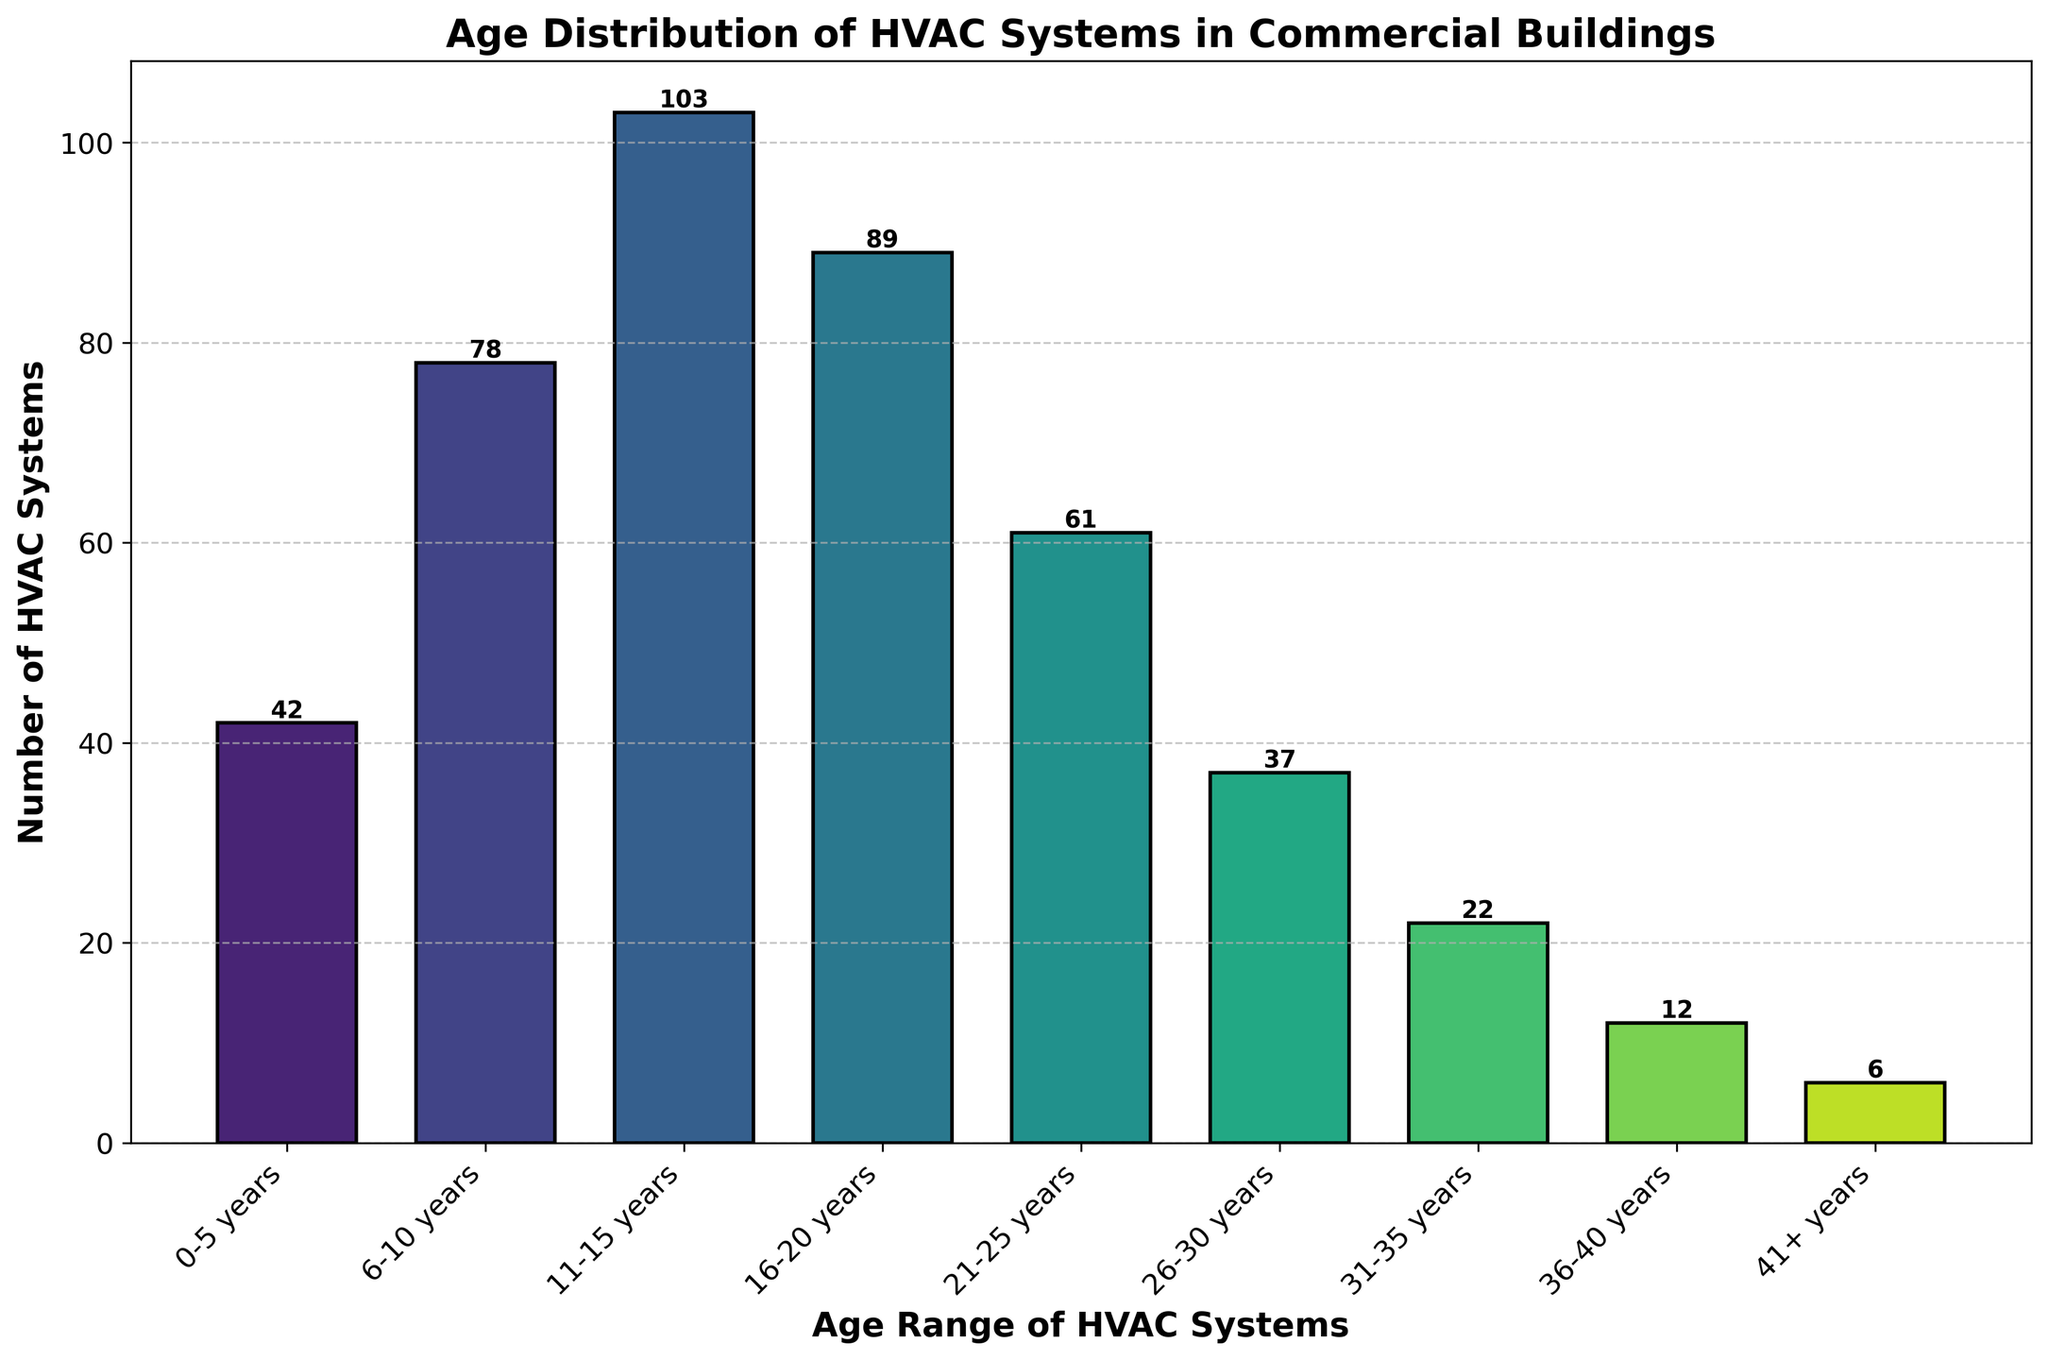What is the title of the histogram? The title of the histogram is the text at the top of the plot that provides context about the data displayed. In this case, it is written in bold and is easily noticeable.
Answer: Age Distribution of HVAC Systems in Commercial Buildings Which age range has the highest number of HVAC systems? To find the age range with the highest number of HVAC systems, look for the tallest bar in the histogram. The tallest bar represents the age range of 11-15 years.
Answer: 11-15 years What is the total number of HVAC systems that are 20 years old or younger? To find the total number of HVAC systems that are 20 years old or younger, sum the counts of the first four age ranges: 0-5 years (42), 6-10 years (78), 11-15 years (103), and 16-20 years (89). 42 + 78 + 103 + 89 = 312.
Answer: 312 How many more HVAC systems are there in the 11-15 years range compared to the 41+ years range? Subtract the number of HVAC systems in the 41+ years range (6) from the number of HVAC systems in the 11-15 years range (103). 103 - 6 = 97.
Answer: 97 Which age range shows the steepest decline in the number of HVAC systems compared to the previous age range? To find the steepest decline, compare the differences in the number of HVAC systems between consecutive age ranges. The steepest decline is between the 16-20 years range (89) and the 21-25 years range (61). The difference is 89 - 61 = 28.
Answer: 16-20 to 21-25 years How many age ranges have more than 50 HVAC systems? Count the age ranges with more than 50 HVAC systems: 6-10 years (78), 11-15 years (103), 16-20 years (89), and 21-25 years (61). This gives us four age ranges.
Answer: 4 What is the average number of HVAC systems in the age ranges from 21-25 years to 36-40 years? To find the average, sum the number of HVAC systems in the age ranges 21-25 years (61), 26-30 years (37), 31-35 years (22), 36-40 years (12), then divide by the number of age ranges (4). (61 + 37 + 22 + 12) / 4 = 33.
Answer: 33 What percentage of the total HVAC systems do those aged 0-10 years constitute? Calculate the total number of HVAC systems, which is the sum of all age ranges (450). Then, add the number of HVAC systems aged 0-10 years (42 + 78 = 120). Divide the number of HVAC systems aged 0-10 years by the total number and multiply by 100 to get the percentage. (120 / 450) * 100 = 26.7%.
Answer: 26.7% Which age range shows the smallest number of HVAC systems still in use? To find the age range with the smallest number of HVAC systems, look for the shortest bar in the histogram. The shortest bar represents the age range of 41+ years.
Answer: 41+ years 